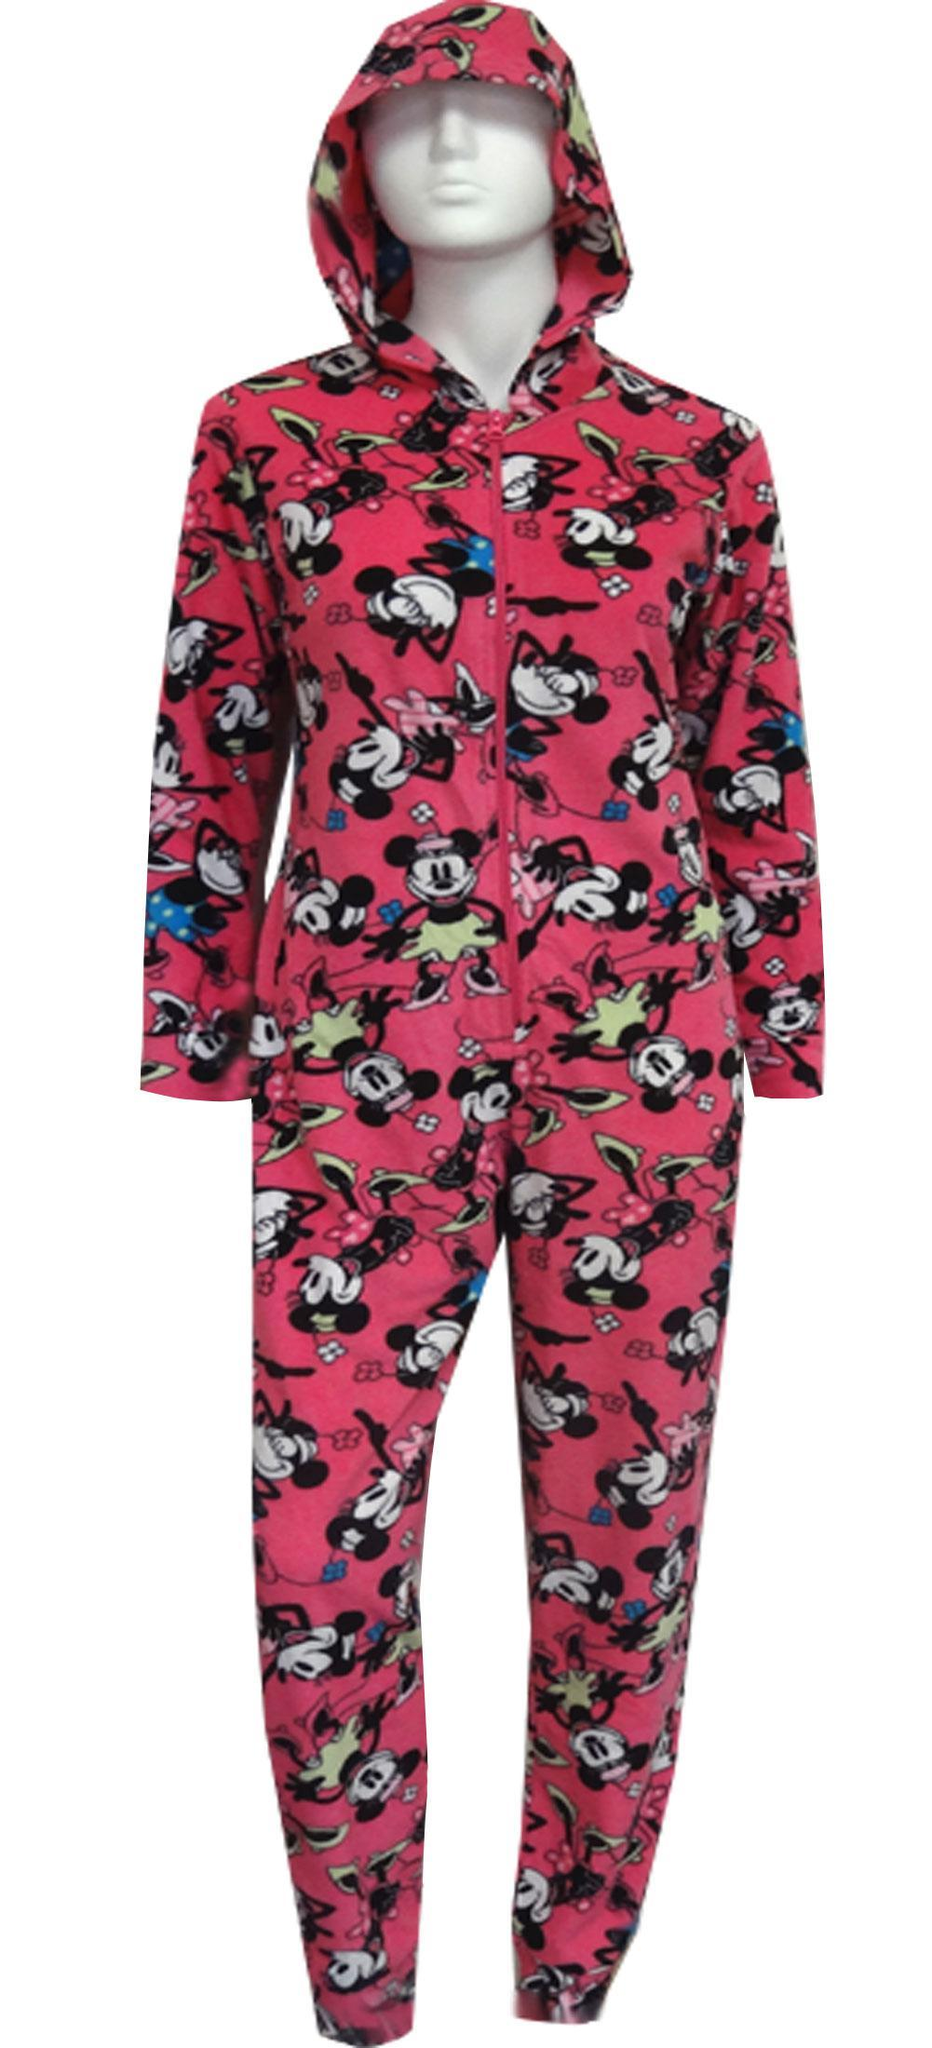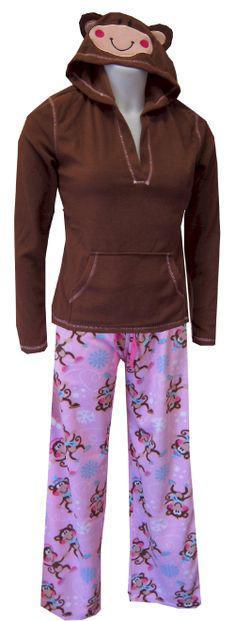The first image is the image on the left, the second image is the image on the right. Evaluate the accuracy of this statement regarding the images: "There is 1 or more woman modeling pajama's.". Is it true? Answer yes or no. No. 